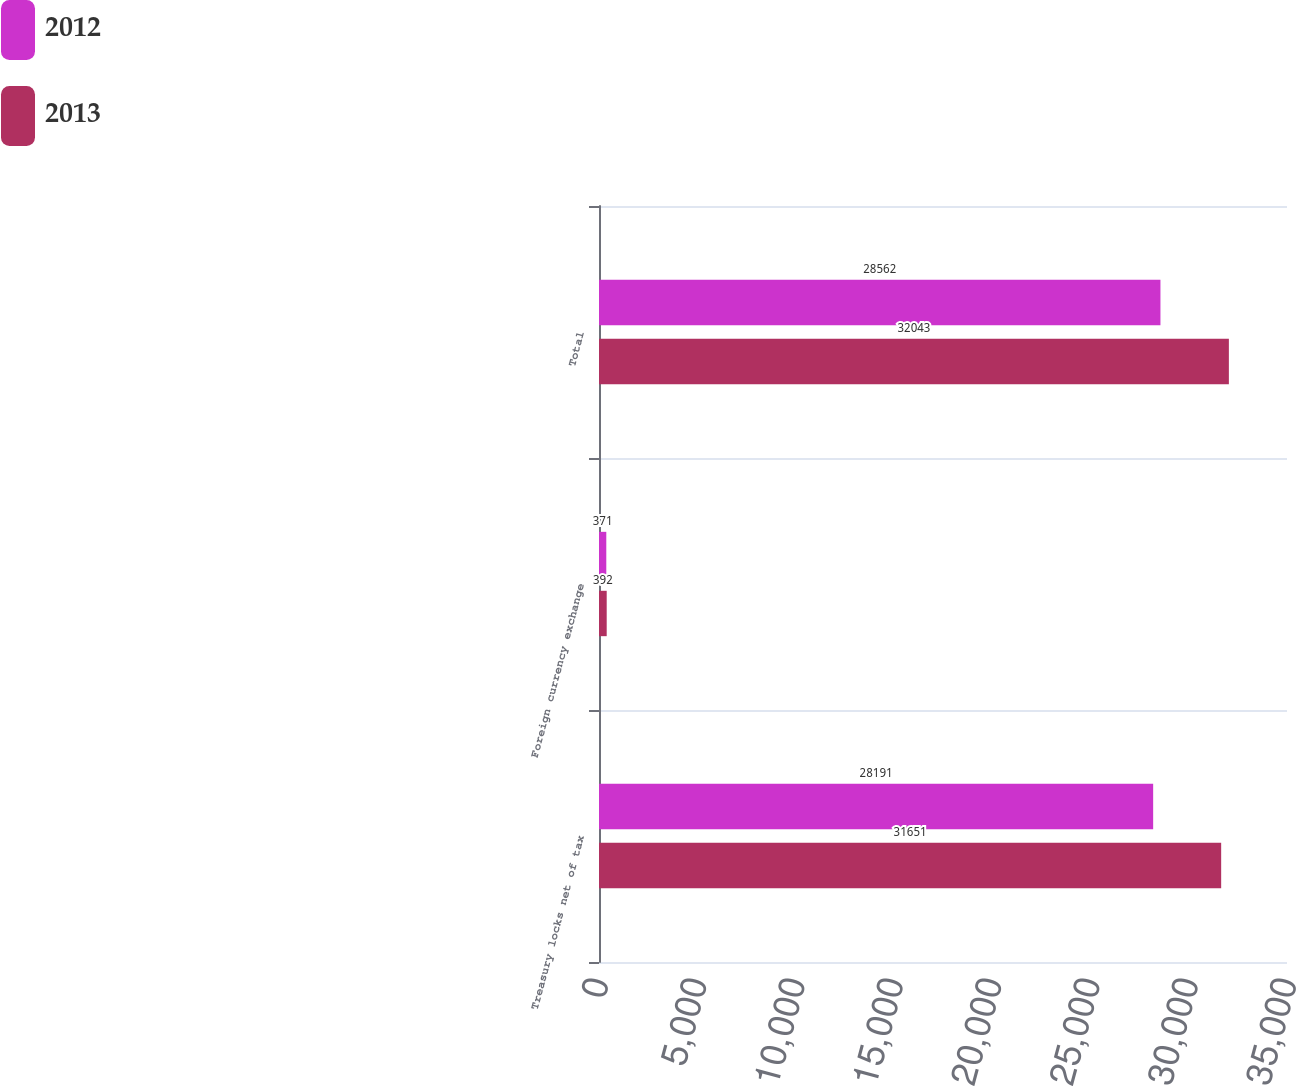Convert chart to OTSL. <chart><loc_0><loc_0><loc_500><loc_500><stacked_bar_chart><ecel><fcel>Treasury locks net of tax<fcel>Foreign currency exchange<fcel>Total<nl><fcel>2012<fcel>28191<fcel>371<fcel>28562<nl><fcel>2013<fcel>31651<fcel>392<fcel>32043<nl></chart> 